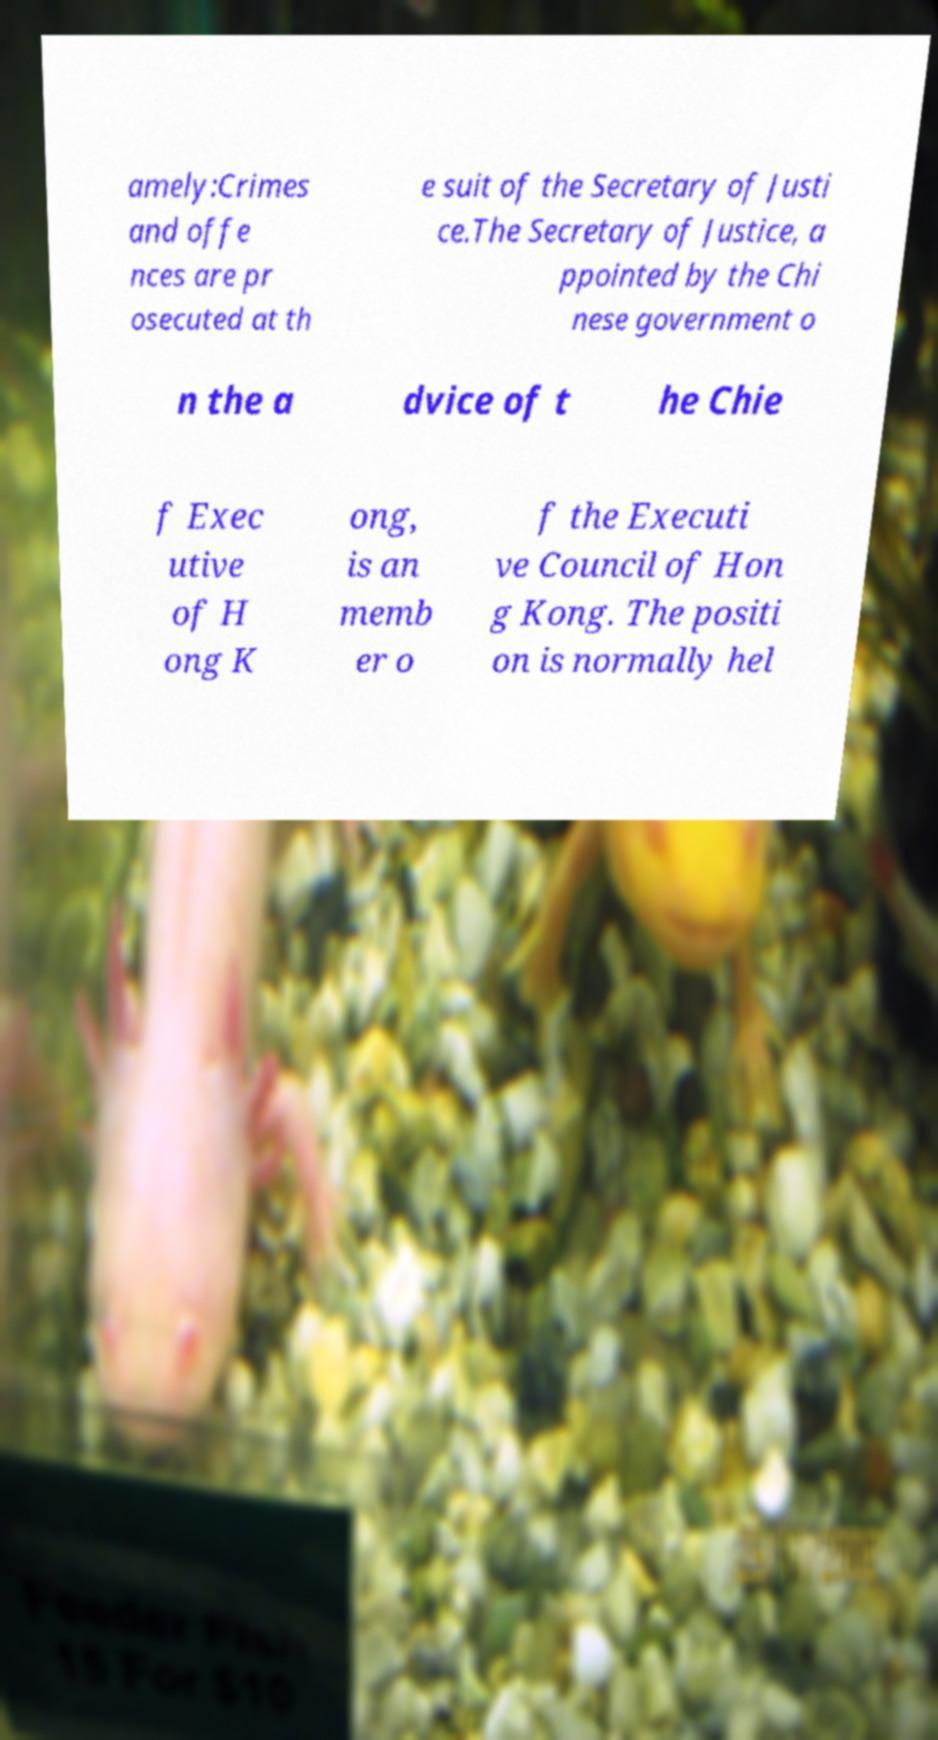Can you accurately transcribe the text from the provided image for me? amely:Crimes and offe nces are pr osecuted at th e suit of the Secretary of Justi ce.The Secretary of Justice, a ppointed by the Chi nese government o n the a dvice of t he Chie f Exec utive of H ong K ong, is an memb er o f the Executi ve Council of Hon g Kong. The positi on is normally hel 